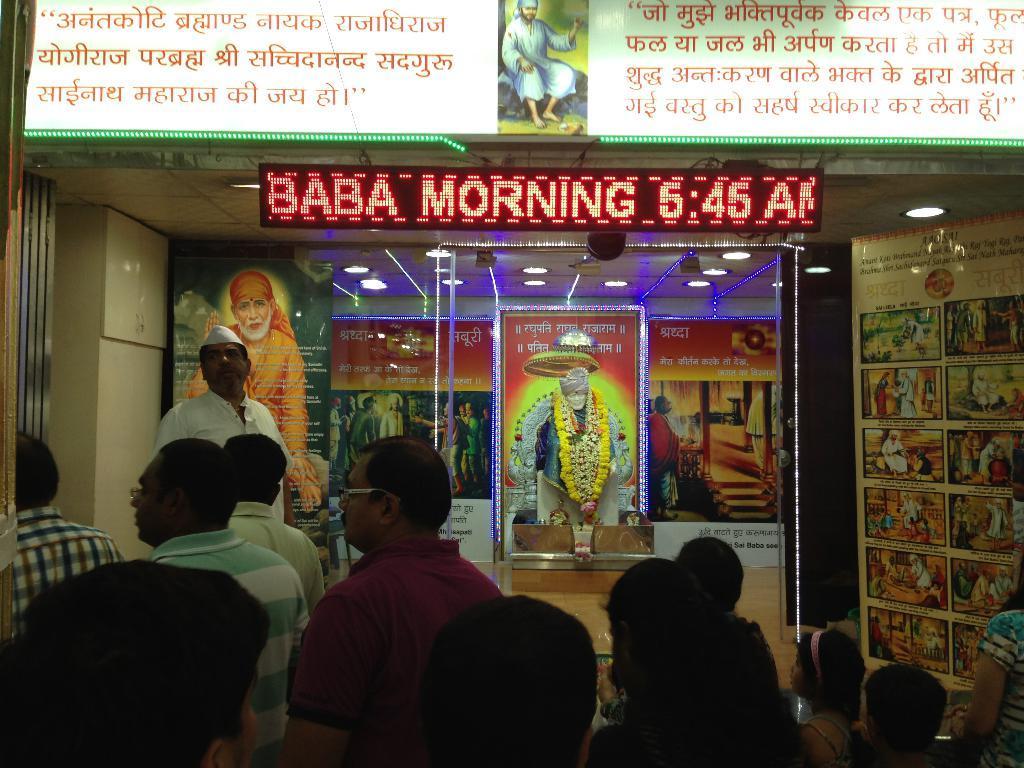In one or two sentences, can you explain what this image depicts? There are people at the bottom side of the image and there is a statue in the center of the image and there are lights and posters in the image. 